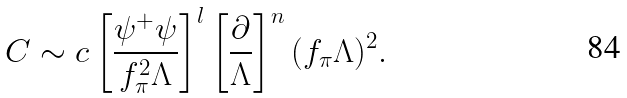Convert formula to latex. <formula><loc_0><loc_0><loc_500><loc_500>C \sim c \left [ \frac { \psi ^ { + } \psi } { f _ { \pi } ^ { 2 } \Lambda } \right ] ^ { l } \left [ \frac { \partial } { \Lambda } \right ] ^ { n } ( f _ { \pi } \Lambda ) ^ { 2 } .</formula> 